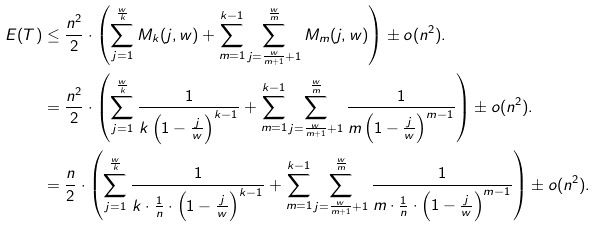<formula> <loc_0><loc_0><loc_500><loc_500>E ( T ) & \leq \frac { n ^ { 2 } } { 2 } \cdot \left ( \sum _ { j = 1 } ^ { \frac { w } { k } } M _ { k } ( j , w ) + \sum _ { m = 1 } ^ { k - 1 } \sum _ { j = \frac { w } { m + 1 } + 1 } ^ { \frac { w } { m } } M _ { m } ( j , w ) \right ) \pm o ( n ^ { 2 } ) . \\ & = \frac { n ^ { 2 } } { 2 } \cdot \left ( \sum _ { j = 1 } ^ { \frac { w } { k } } \frac { 1 } { k \left ( 1 - \frac { j } { w } \right ) ^ { k - 1 } } + \sum _ { m = 1 } ^ { k - 1 } \sum _ { j = \frac { w } { m + 1 } + 1 } ^ { \frac { w } { m } } \frac { 1 } { m \left ( 1 - \frac { j } { w } \right ) ^ { m - 1 } } \right ) \pm o ( n ^ { 2 } ) . \\ & = \frac { n } { 2 } \cdot \left ( \sum _ { j = 1 } ^ { \frac { w } { k } } \frac { 1 } { k \cdot \frac { 1 } { n } \cdot \left ( 1 - \frac { j } { w } \right ) ^ { k - 1 } } + \sum _ { m = 1 } ^ { k - 1 } \sum _ { j = \frac { w } { m + 1 } + 1 } ^ { \frac { w } { m } } \frac { 1 } { m \cdot \frac { 1 } { n } \cdot \left ( 1 - \frac { j } { w } \right ) ^ { m - 1 } } \right ) \pm o ( n ^ { 2 } ) .</formula> 